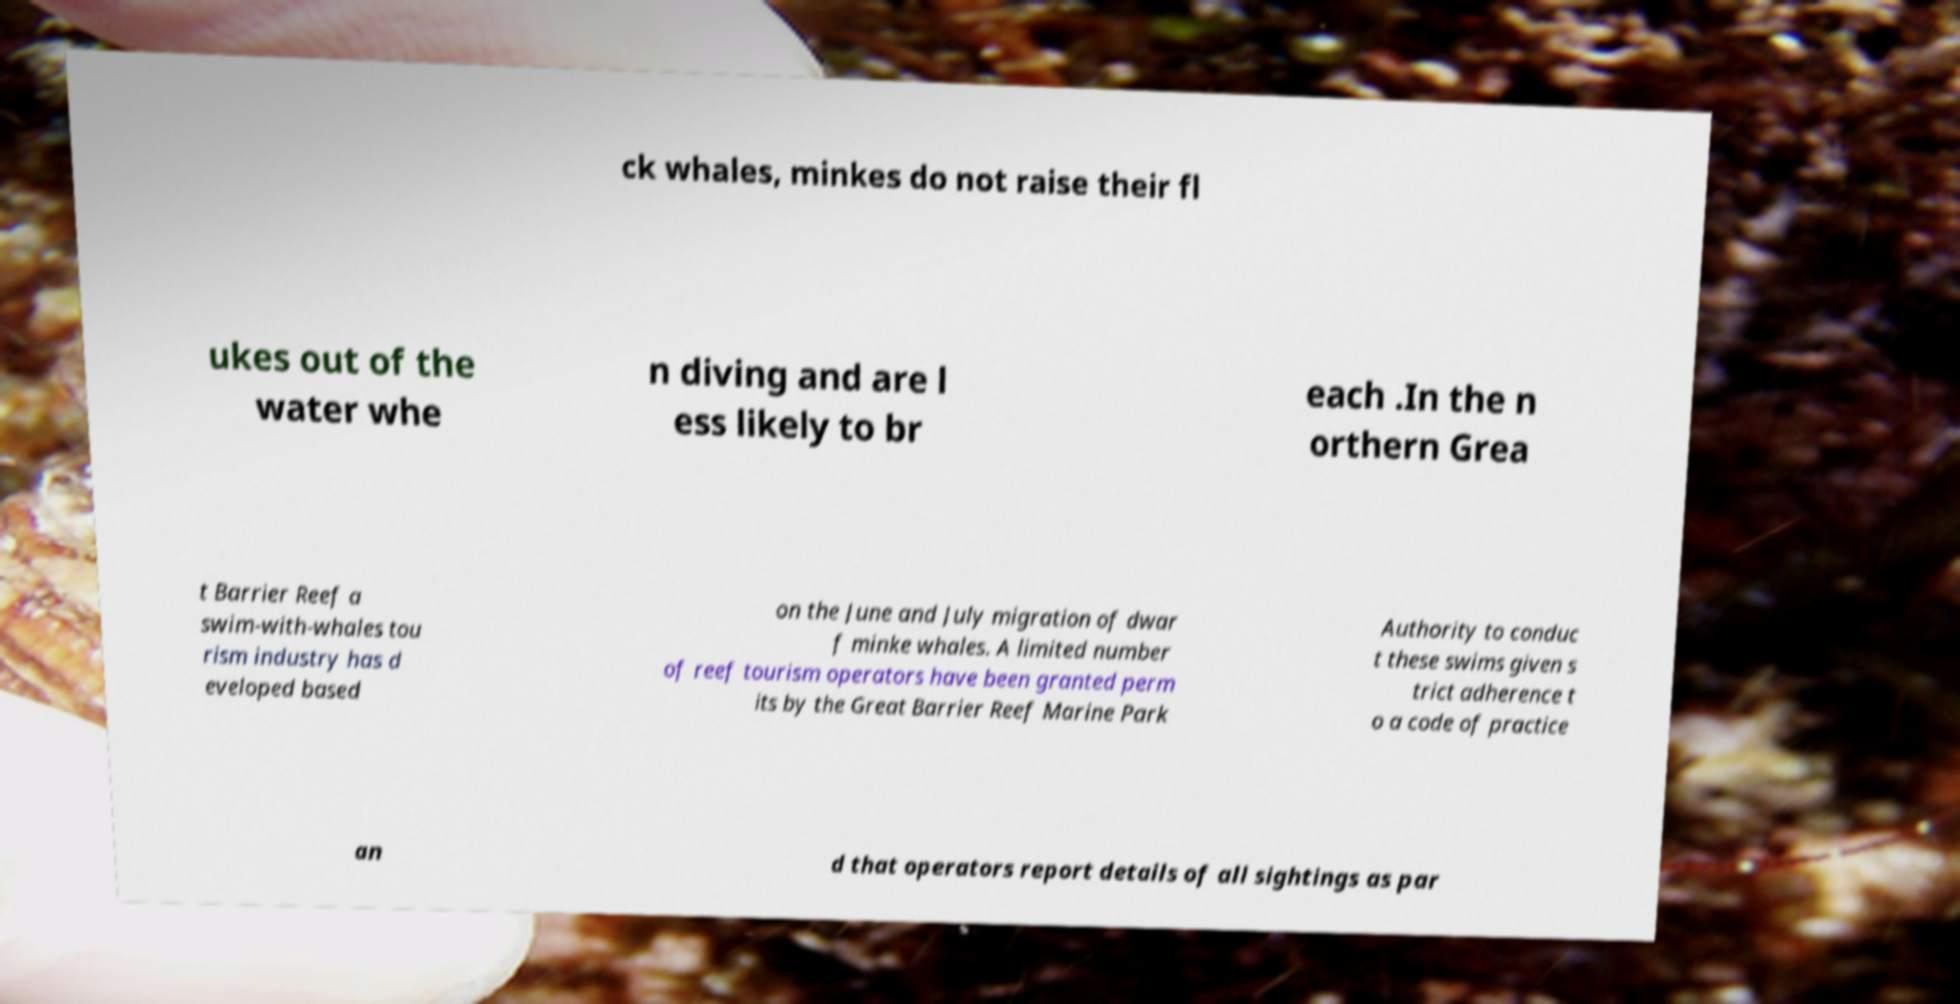Can you accurately transcribe the text from the provided image for me? ck whales, minkes do not raise their fl ukes out of the water whe n diving and are l ess likely to br each .In the n orthern Grea t Barrier Reef a swim-with-whales tou rism industry has d eveloped based on the June and July migration of dwar f minke whales. A limited number of reef tourism operators have been granted perm its by the Great Barrier Reef Marine Park Authority to conduc t these swims given s trict adherence t o a code of practice an d that operators report details of all sightings as par 